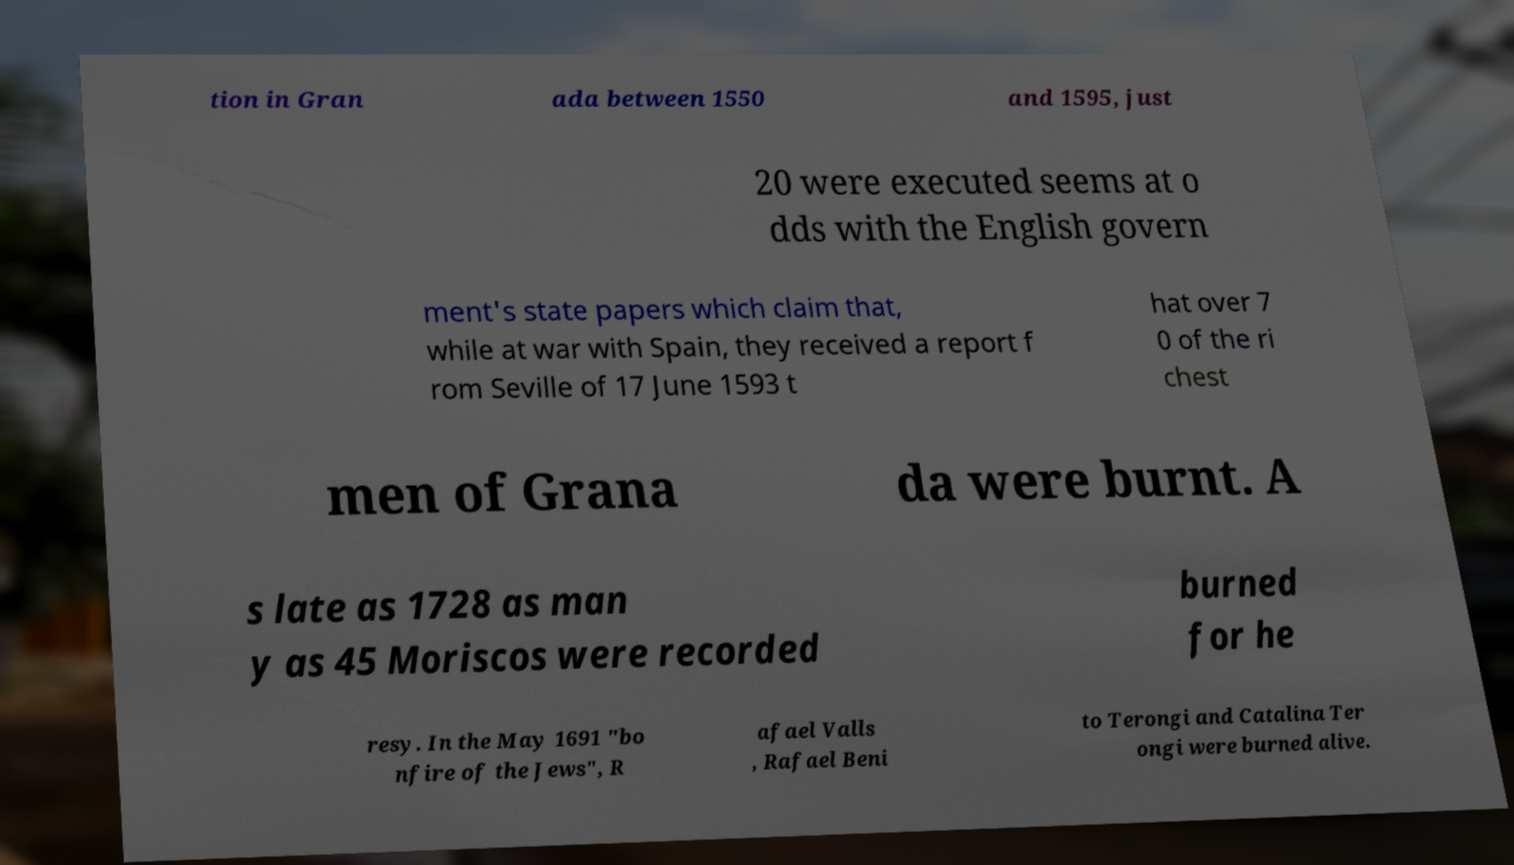Could you extract and type out the text from this image? tion in Gran ada between 1550 and 1595, just 20 were executed seems at o dds with the English govern ment's state papers which claim that, while at war with Spain, they received a report f rom Seville of 17 June 1593 t hat over 7 0 of the ri chest men of Grana da were burnt. A s late as 1728 as man y as 45 Moriscos were recorded burned for he resy. In the May 1691 "bo nfire of the Jews", R afael Valls , Rafael Beni to Terongi and Catalina Ter ongi were burned alive. 